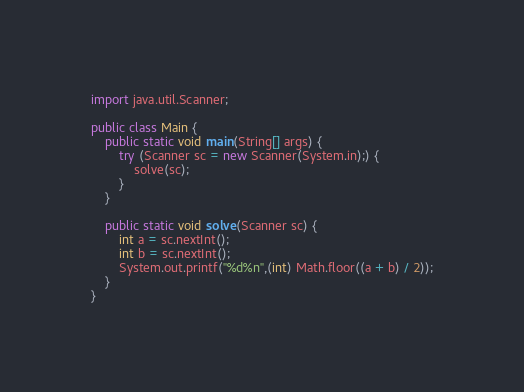<code> <loc_0><loc_0><loc_500><loc_500><_Java_>import java.util.Scanner;

public class Main {
    public static void main(String[] args) {
        try (Scanner sc = new Scanner(System.in);) {
            solve(sc);
        }
    }

    public static void solve(Scanner sc) {
        int a = sc.nextInt();
        int b = sc.nextInt();
        System.out.printf("%d%n",(int) Math.floor((a + b) / 2));
    }
}</code> 